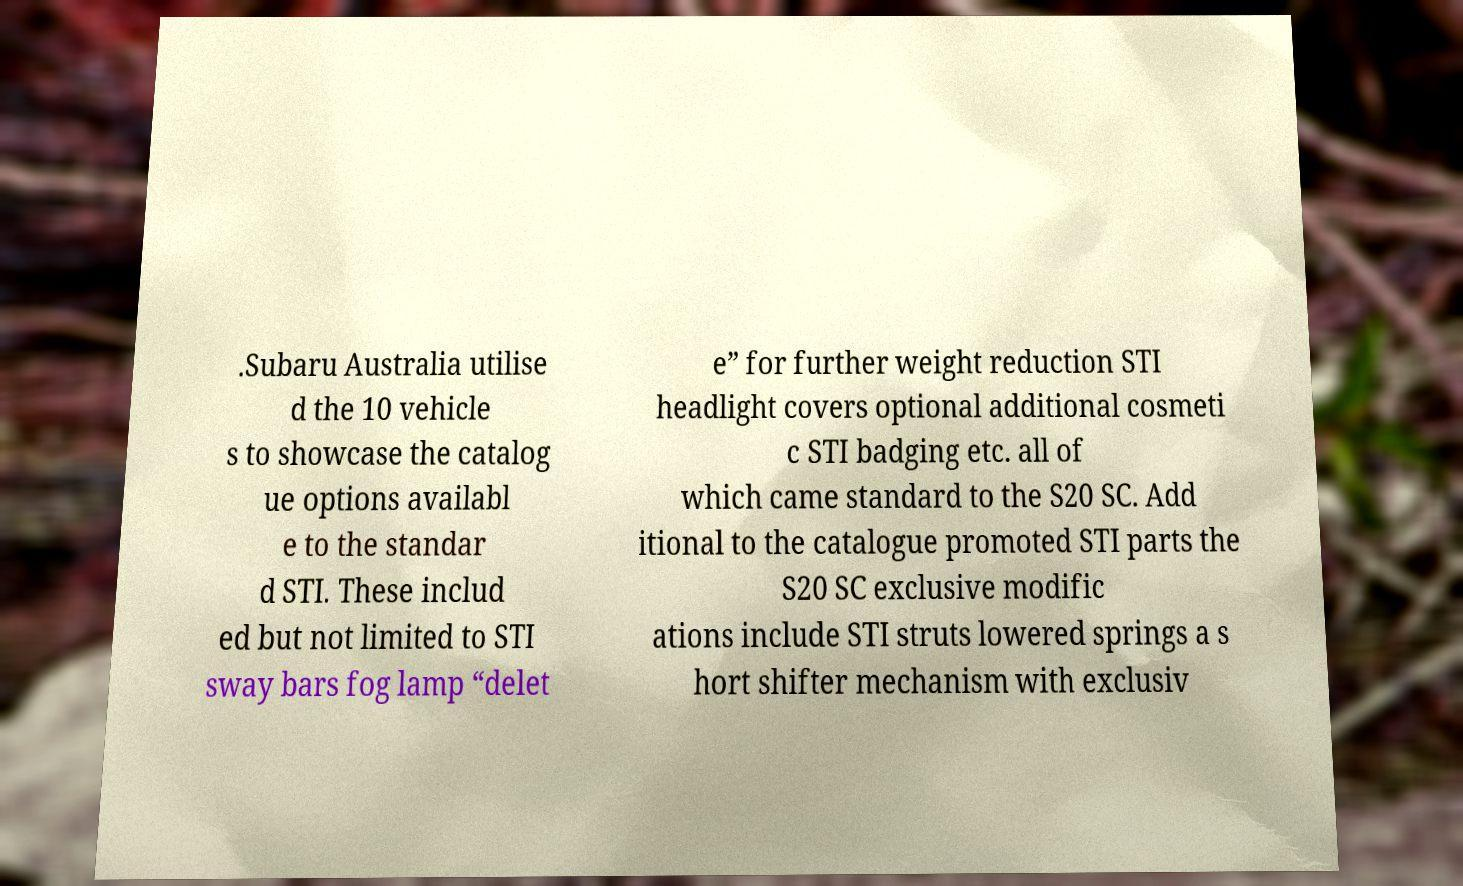Please identify and transcribe the text found in this image. .Subaru Australia utilise d the 10 vehicle s to showcase the catalog ue options availabl e to the standar d STI. These includ ed but not limited to STI sway bars fog lamp “delet e” for further weight reduction STI headlight covers optional additional cosmeti c STI badging etc. all of which came standard to the S20 SC. Add itional to the catalogue promoted STI parts the S20 SC exclusive modific ations include STI struts lowered springs a s hort shifter mechanism with exclusiv 